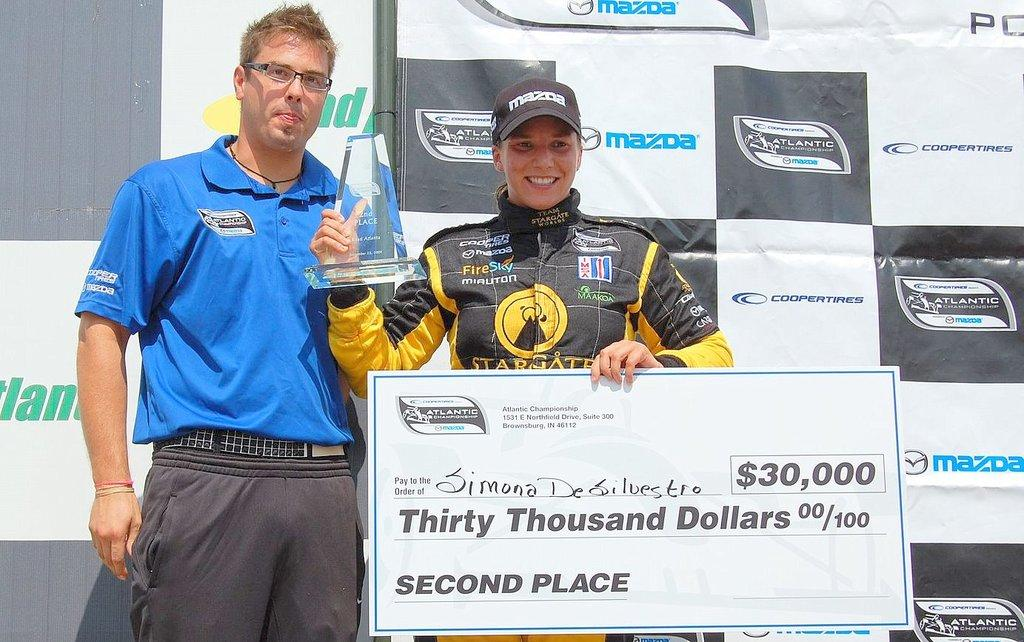<image>
Provide a brief description of the given image. a man in a yellow and black jersey holding a check for $30,000 for second place 